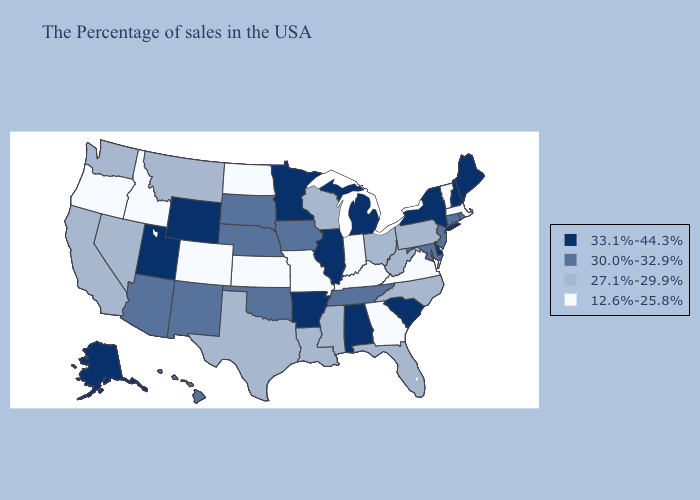Is the legend a continuous bar?
Answer briefly. No. Name the states that have a value in the range 33.1%-44.3%?
Short answer required. Maine, New Hampshire, New York, Delaware, South Carolina, Michigan, Alabama, Illinois, Arkansas, Minnesota, Wyoming, Utah, Alaska. Does Oklahoma have the lowest value in the South?
Quick response, please. No. What is the lowest value in the USA?
Short answer required. 12.6%-25.8%. What is the highest value in states that border Nebraska?
Quick response, please. 33.1%-44.3%. Name the states that have a value in the range 12.6%-25.8%?
Short answer required. Massachusetts, Vermont, Virginia, Georgia, Kentucky, Indiana, Missouri, Kansas, North Dakota, Colorado, Idaho, Oregon. Is the legend a continuous bar?
Keep it brief. No. What is the value of Vermont?
Short answer required. 12.6%-25.8%. Which states have the highest value in the USA?
Short answer required. Maine, New Hampshire, New York, Delaware, South Carolina, Michigan, Alabama, Illinois, Arkansas, Minnesota, Wyoming, Utah, Alaska. Does Vermont have the highest value in the Northeast?
Quick response, please. No. Does the map have missing data?
Write a very short answer. No. Name the states that have a value in the range 33.1%-44.3%?
Concise answer only. Maine, New Hampshire, New York, Delaware, South Carolina, Michigan, Alabama, Illinois, Arkansas, Minnesota, Wyoming, Utah, Alaska. What is the value of Washington?
Write a very short answer. 27.1%-29.9%. What is the value of Nebraska?
Quick response, please. 30.0%-32.9%. Does Michigan have the highest value in the USA?
Keep it brief. Yes. 